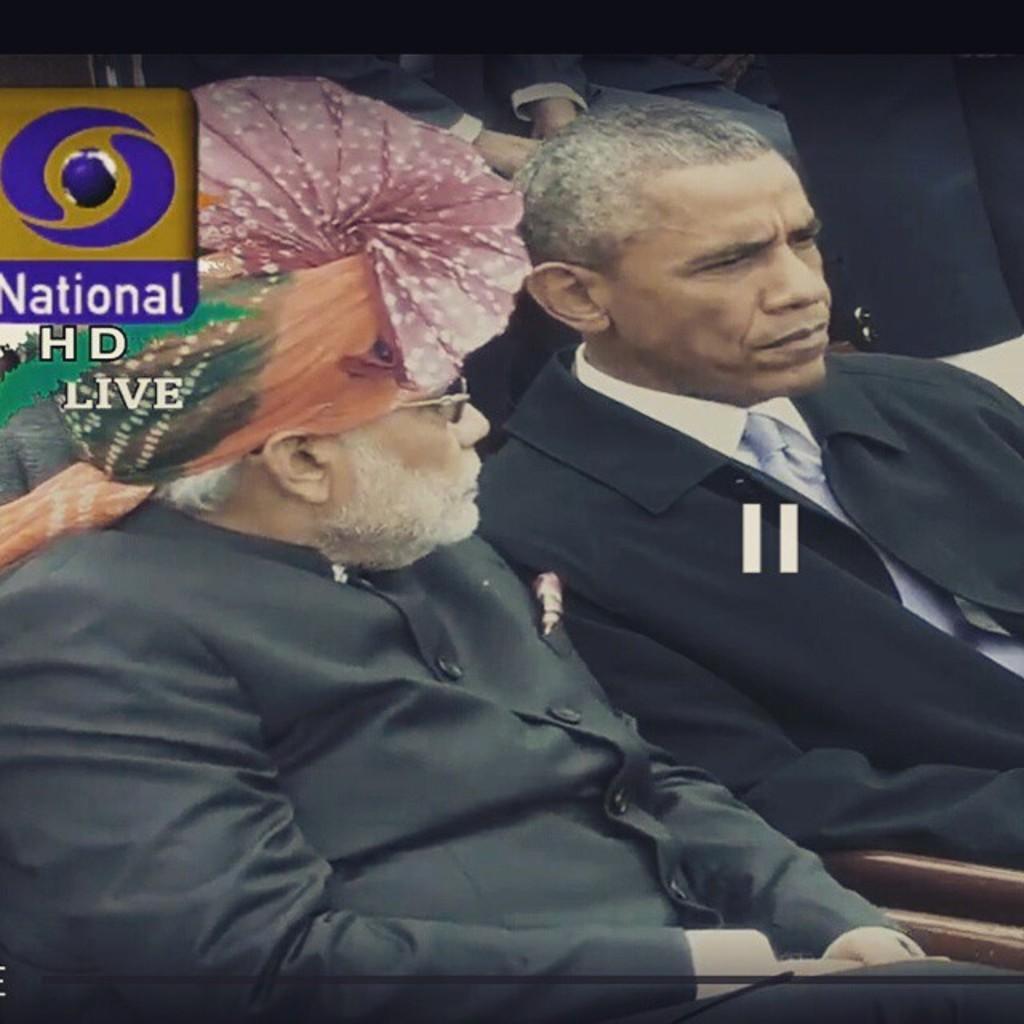Could you give a brief overview of what you see in this image? In this image I can see the television screen in which I can see two persons wearing black colored dresses are sitting and I can see a person is wearing a turban which is orange, pink and green in color. In the background I can see few other persons and to the left top of the image I can see the logo of the channel. 